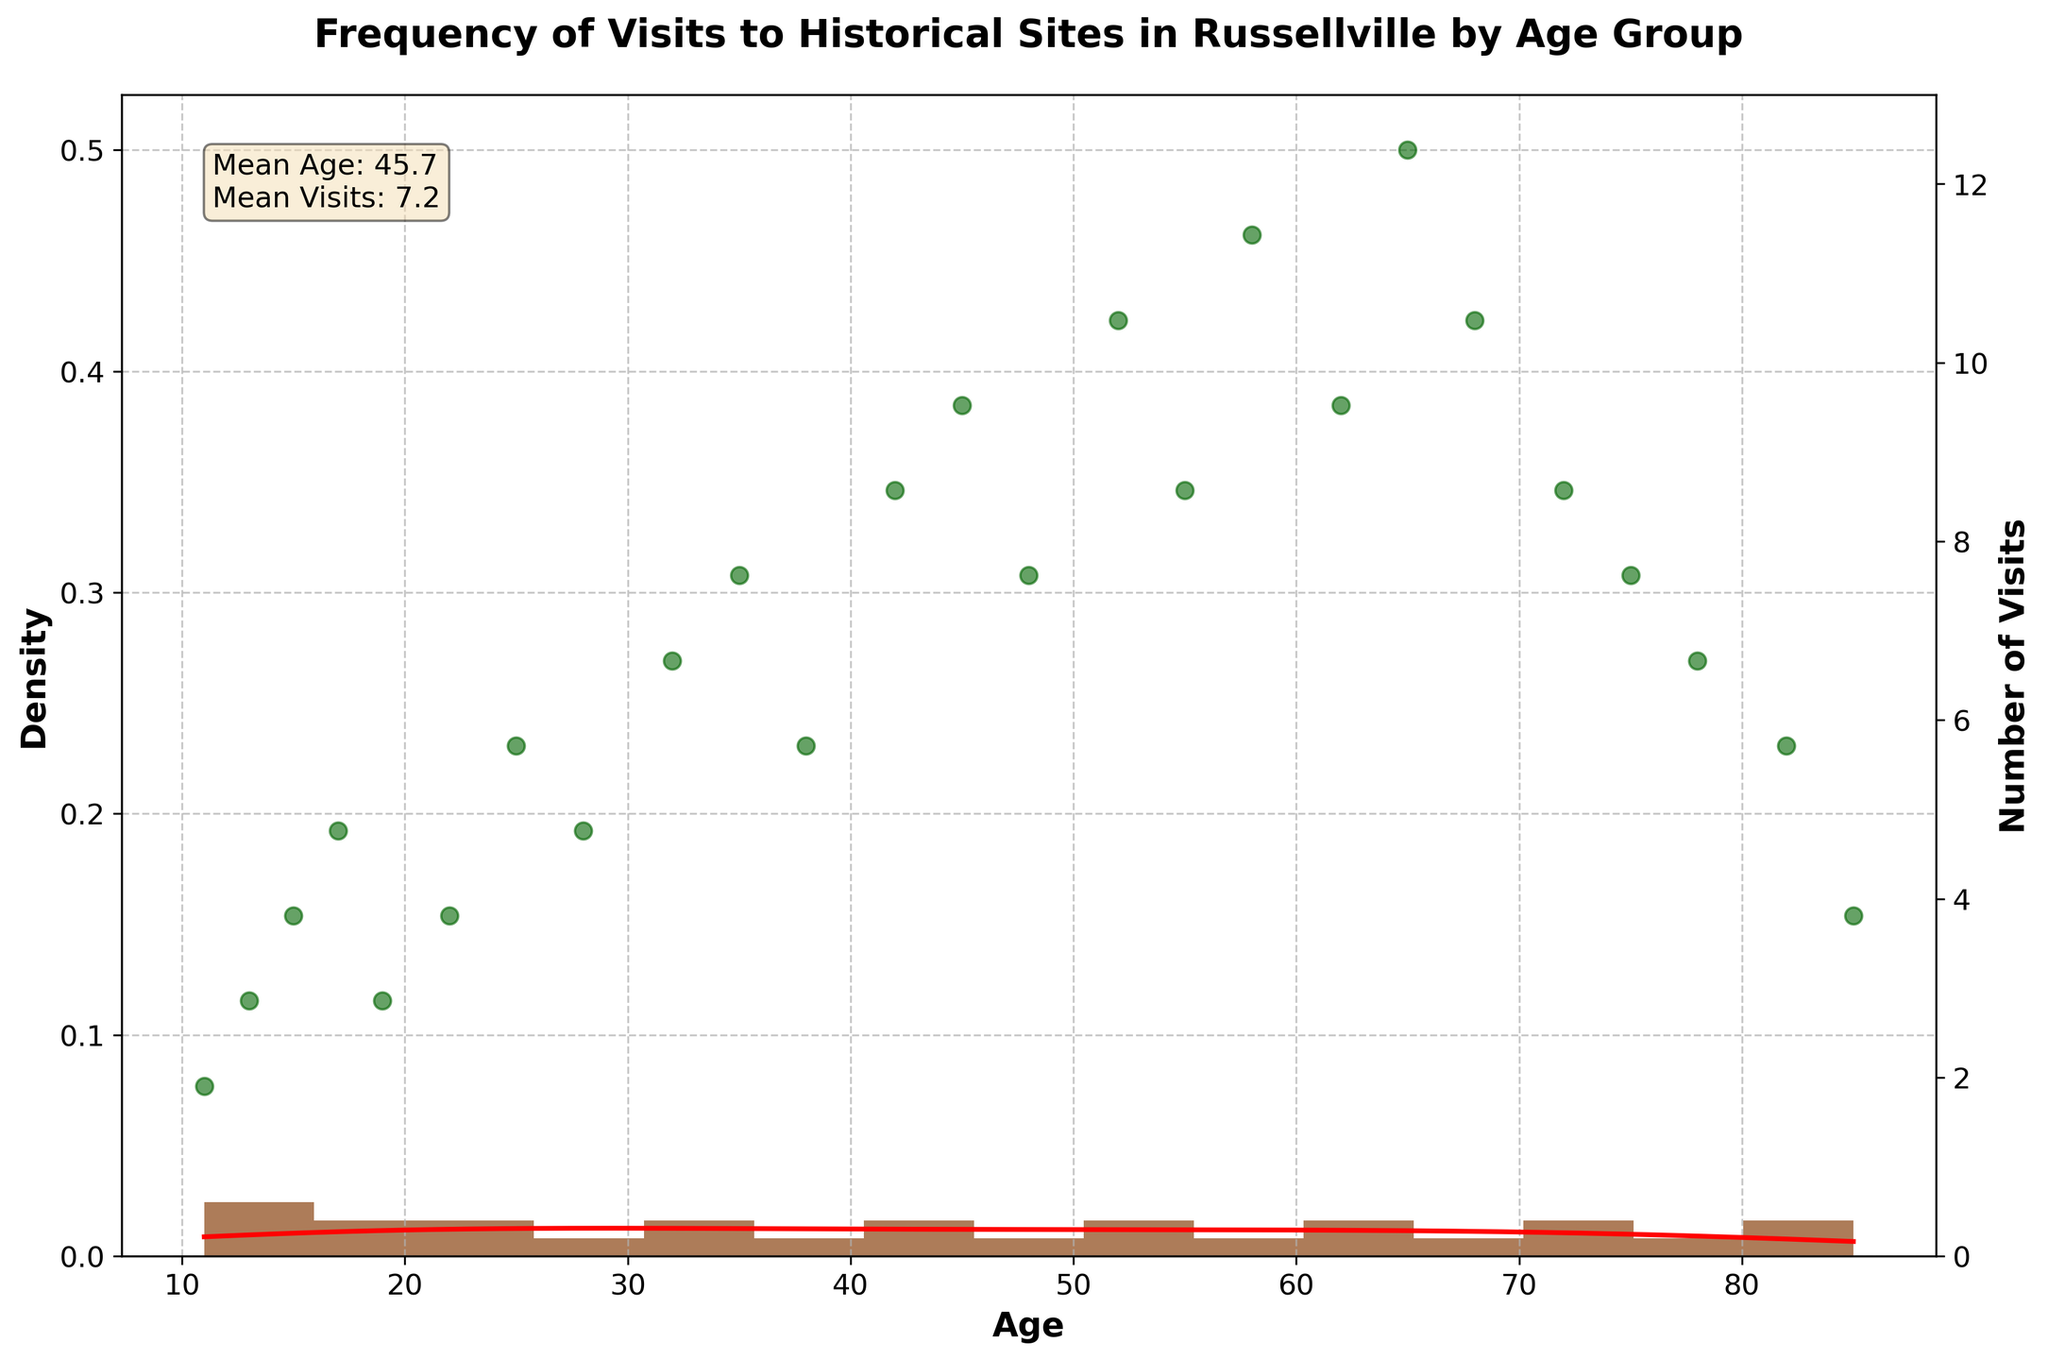What's the title of the figure? The title usually appears at the top of the figure. In this case, it reads "Frequency of Visits to Historical Sites in Russellville by Age Group."
Answer: Frequency of Visits to Historical Sites in Russellville by Age Group What does the x-axis represent? The label on the x-axis indicates the variable it represents. Here, it is labeled as 'Age,' which means the x-axis represents the age of the visitors.
Answer: Age What does the y-axis on the right-hand side represent? The right-hand side y-axis label indicates it's for the "Number of Visits." It shows the range of visits from 0 to the maximum number in the dataset.
Answer: Number of Visits What color is the histogram? By observing the color of the bars in the histogram, we can see that it is brown.
Answer: Brown What does the red line represent? The red line represents the KDE (Kernel Density Estimate) curve, which shows the smoothed density estimate of the age distribution.
Answer: KDE curve How many age groups have 10 or more visits? By examining the scatterplot points and the right-hand side y-axis, we can identify the age groups with 10 or more visits. These are ages 45, 52, 58, 65, and 68.
Answer: 5 age groups What is the average number of visits for people aged 55 and older? We need to identify the visits for ages 55, 58, 62, 65, 68, 72, 75, 78, 82, and 85. Summing those values: 9 + 12 + 10 + 13 + 11 + 9 + 8 + 7 + 6 + 4 = 89. We then divide by the number of age groups, which is 10, so 89 / 10 = 8.9.
Answer: 8.9 Which age group has the highest number of visits? By checking the scatter plot points, the age group with the highest point is at age 65, with 13 visits.
Answer: Age 65 How does the number of visits change from age 22 to age 35? The scatter plot points show that visits increase from age 22 (4 visits) to age 35 (8 visits). This indicates a positive change of 4 visits.
Answer: Increases by 4 visits Which age group has the lowest density according to the KDE curve? The lowest point on the KDE curve represents the age group with the least density. This occurs at the youngest age (11 years).
Answer: Age 11 